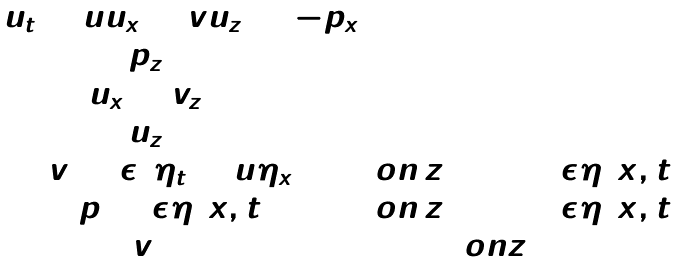Convert formula to latex. <formula><loc_0><loc_0><loc_500><loc_500>\begin{array} { c c } u _ { t } + u u _ { x } + v u _ { z } = - p _ { x } & \\ p _ { z } = 0 & \\ u _ { x } + v _ { z } = 0 & \\ u _ { z } = 0 & \\ v = \epsilon ( \eta _ { t } + u \eta _ { x } ) \, & o n \, z = 1 + \epsilon \eta ( x , t ) \\ p = \epsilon \eta ( x , t ) \, & o n \, z = 1 + \epsilon \eta ( x , t ) \\ v = 0 \, & o n z = 0 \end{array}</formula> 